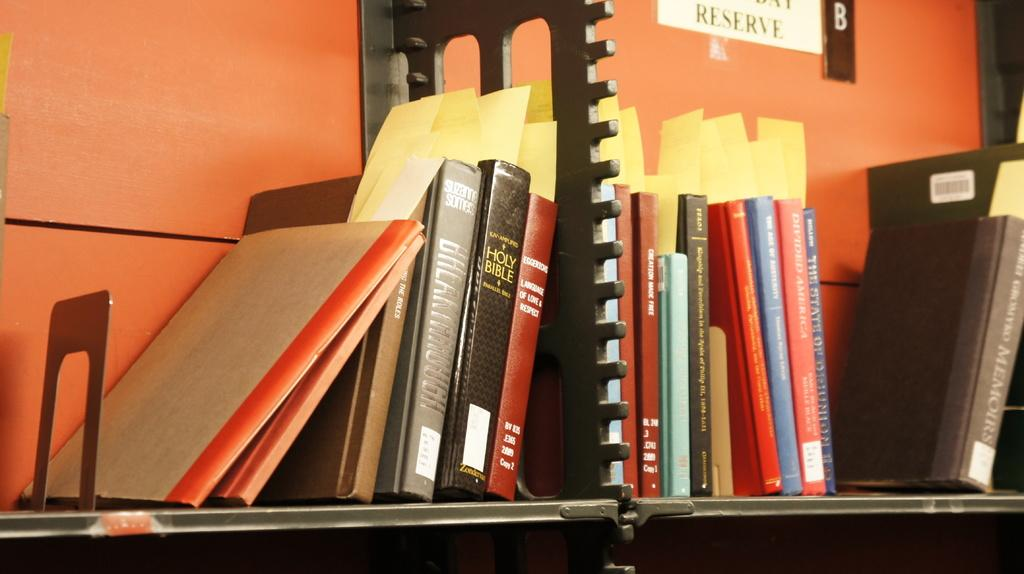<image>
Offer a succinct explanation of the picture presented. A series of books are stacked side to side with a copy of the holy bible on the left. 